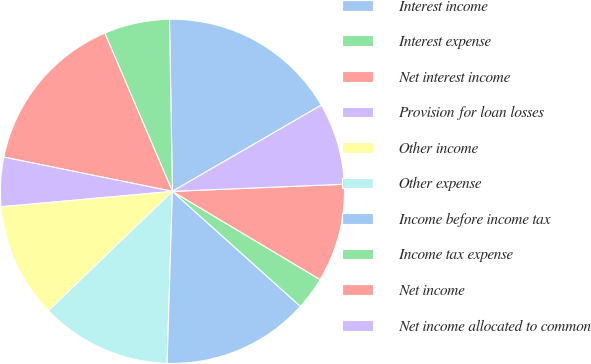Convert chart. <chart><loc_0><loc_0><loc_500><loc_500><pie_chart><fcel>Interest income<fcel>Interest expense<fcel>Net interest income<fcel>Provision for loan losses<fcel>Other income<fcel>Other expense<fcel>Income before income tax<fcel>Income tax expense<fcel>Net income<fcel>Net income allocated to common<nl><fcel>16.92%<fcel>6.16%<fcel>15.38%<fcel>4.62%<fcel>10.77%<fcel>12.31%<fcel>13.84%<fcel>3.08%<fcel>9.23%<fcel>7.69%<nl></chart> 